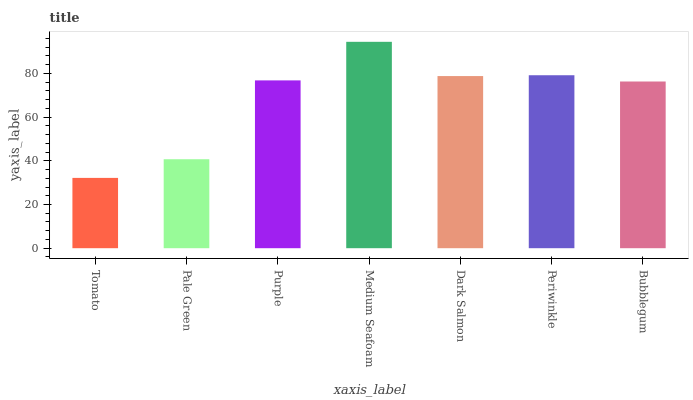Is Tomato the minimum?
Answer yes or no. Yes. Is Medium Seafoam the maximum?
Answer yes or no. Yes. Is Pale Green the minimum?
Answer yes or no. No. Is Pale Green the maximum?
Answer yes or no. No. Is Pale Green greater than Tomato?
Answer yes or no. Yes. Is Tomato less than Pale Green?
Answer yes or no. Yes. Is Tomato greater than Pale Green?
Answer yes or no. No. Is Pale Green less than Tomato?
Answer yes or no. No. Is Purple the high median?
Answer yes or no. Yes. Is Purple the low median?
Answer yes or no. Yes. Is Dark Salmon the high median?
Answer yes or no. No. Is Periwinkle the low median?
Answer yes or no. No. 